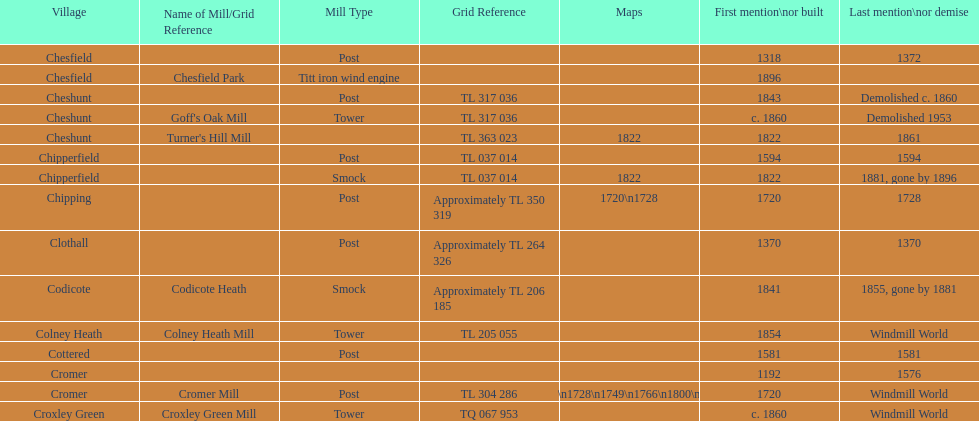What is the name of the only "c" mill located in colney health? Colney Heath Mill. 